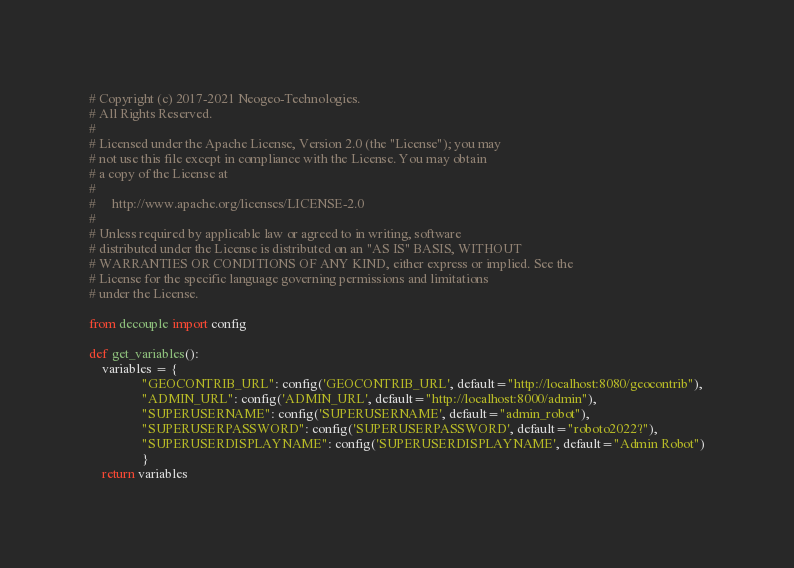Convert code to text. <code><loc_0><loc_0><loc_500><loc_500><_Python_># Copyright (c) 2017-2021 Neogeo-Technologies.
# All Rights Reserved.
#
# Licensed under the Apache License, Version 2.0 (the "License"); you may
# not use this file except in compliance with the License. You may obtain
# a copy of the License at
#
#     http://www.apache.org/licenses/LICENSE-2.0
#
# Unless required by applicable law or agreed to in writing, software
# distributed under the License is distributed on an "AS IS" BASIS, WITHOUT
# WARRANTIES OR CONDITIONS OF ANY KIND, either express or implied. See the
# License for the specific language governing permissions and limitations
# under the License.

from decouple import config

def get_variables():
    variables = {
                "GEOCONTRIB_URL": config('GEOCONTRIB_URL', default="http://localhost:8080/geocontrib"),
                "ADMIN_URL": config('ADMIN_URL', default="http://localhost:8000/admin"),
                "SUPERUSERNAME": config('SUPERUSERNAME', default="admin_robot"),
                "SUPERUSERPASSWORD": config('SUPERUSERPASSWORD', default="roboto2022?"),
                "SUPERUSERDISPLAYNAME": config('SUPERUSERDISPLAYNAME', default="Admin Robot")
                }
    return variables
</code> 